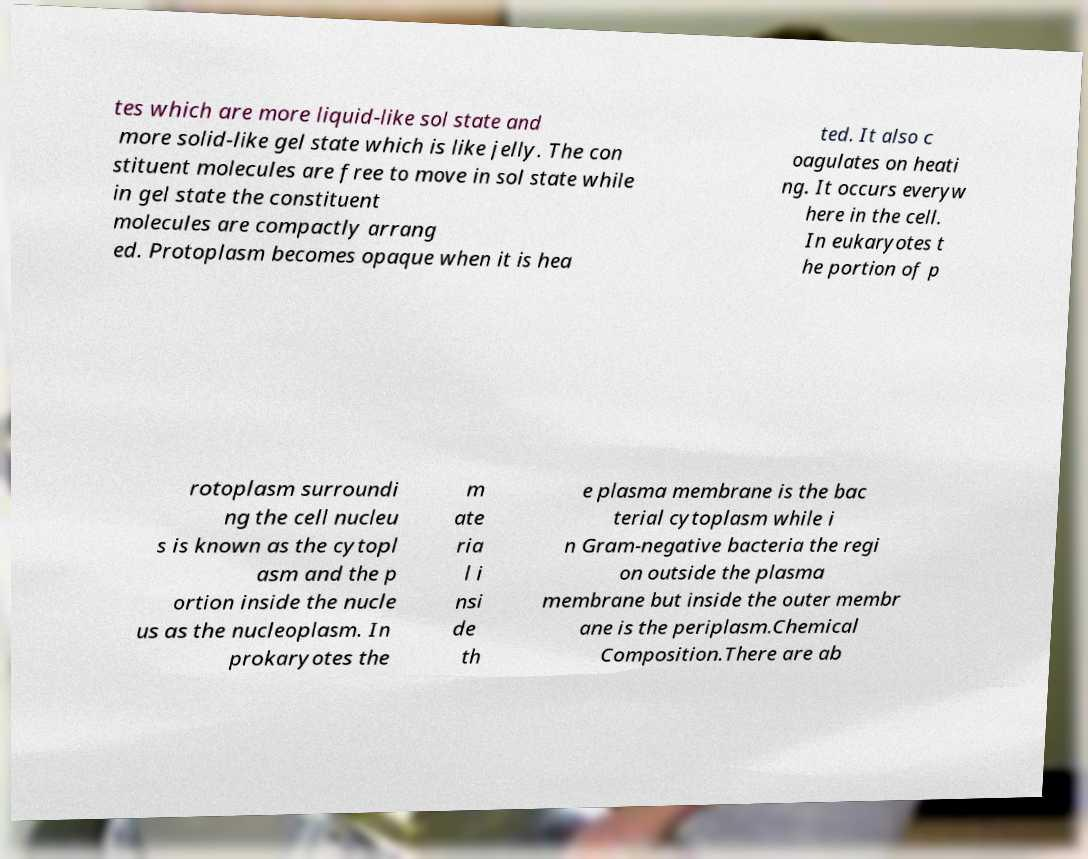Can you accurately transcribe the text from the provided image for me? tes which are more liquid-like sol state and more solid-like gel state which is like jelly. The con stituent molecules are free to move in sol state while in gel state the constituent molecules are compactly arrang ed. Protoplasm becomes opaque when it is hea ted. It also c oagulates on heati ng. It occurs everyw here in the cell. In eukaryotes t he portion of p rotoplasm surroundi ng the cell nucleu s is known as the cytopl asm and the p ortion inside the nucle us as the nucleoplasm. In prokaryotes the m ate ria l i nsi de th e plasma membrane is the bac terial cytoplasm while i n Gram-negative bacteria the regi on outside the plasma membrane but inside the outer membr ane is the periplasm.Chemical Composition.There are ab 